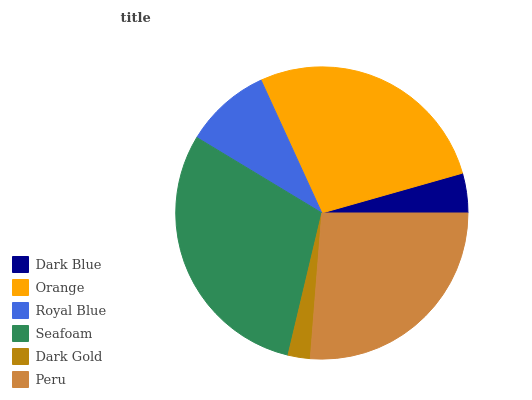Is Dark Gold the minimum?
Answer yes or no. Yes. Is Seafoam the maximum?
Answer yes or no. Yes. Is Orange the minimum?
Answer yes or no. No. Is Orange the maximum?
Answer yes or no. No. Is Orange greater than Dark Blue?
Answer yes or no. Yes. Is Dark Blue less than Orange?
Answer yes or no. Yes. Is Dark Blue greater than Orange?
Answer yes or no. No. Is Orange less than Dark Blue?
Answer yes or no. No. Is Peru the high median?
Answer yes or no. Yes. Is Royal Blue the low median?
Answer yes or no. Yes. Is Royal Blue the high median?
Answer yes or no. No. Is Dark Gold the low median?
Answer yes or no. No. 